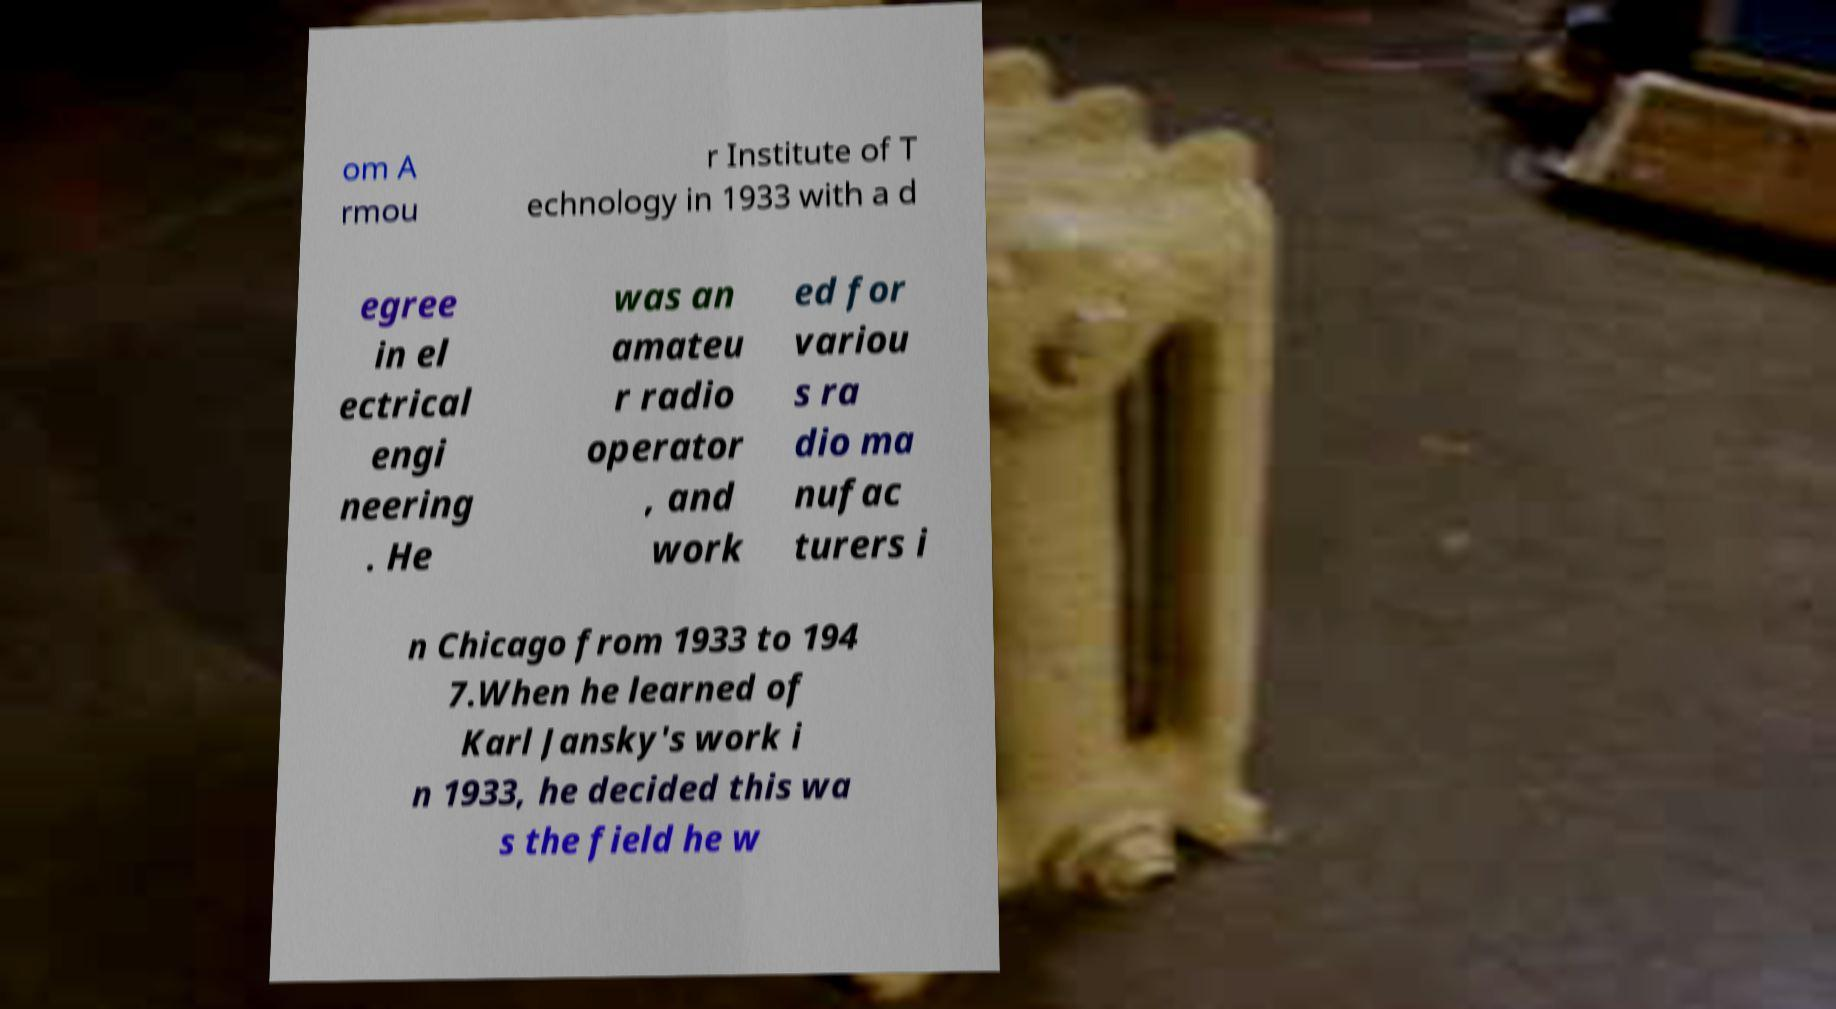Can you read and provide the text displayed in the image?This photo seems to have some interesting text. Can you extract and type it out for me? om A rmou r Institute of T echnology in 1933 with a d egree in el ectrical engi neering . He was an amateu r radio operator , and work ed for variou s ra dio ma nufac turers i n Chicago from 1933 to 194 7.When he learned of Karl Jansky's work i n 1933, he decided this wa s the field he w 